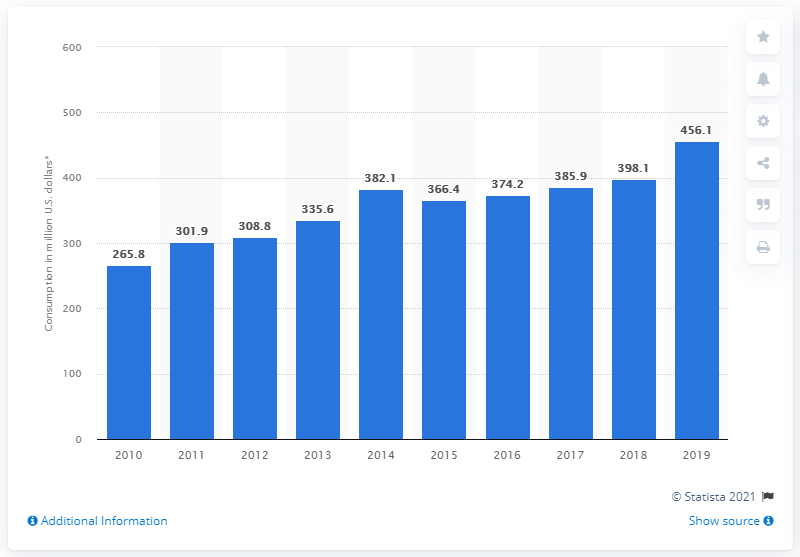Indicate a few pertinent items in this graphic. Internal tourism consumption in the United States generated an estimated 456.1 billion dollars in 2019. 